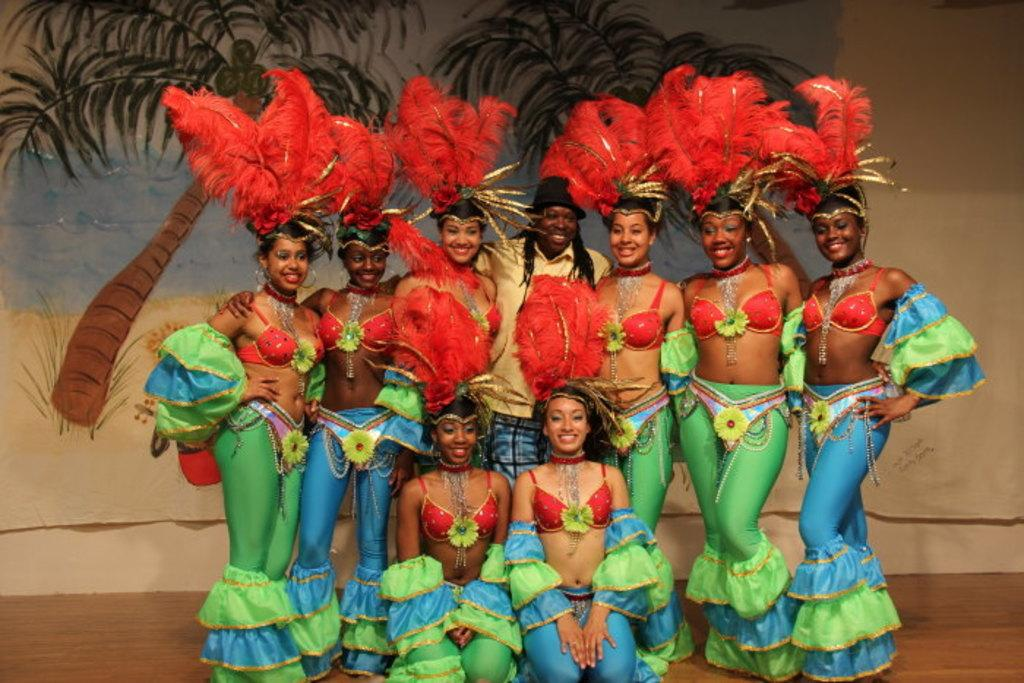How many people are in the image? There are people in the image, but the exact number is not specified. What are the people wearing? The people are wearing different color costumes. What is the surface the people are standing on? The people are standing on a brown surface. What can be seen in the background of the image? There are trees and water visible in the background. How many adjustments were made to the corn in the image? There is no corn present in the image, so no adjustments can be made to it. Can you tell me how many bats are flying in the image? There are no bats visible in the image. 